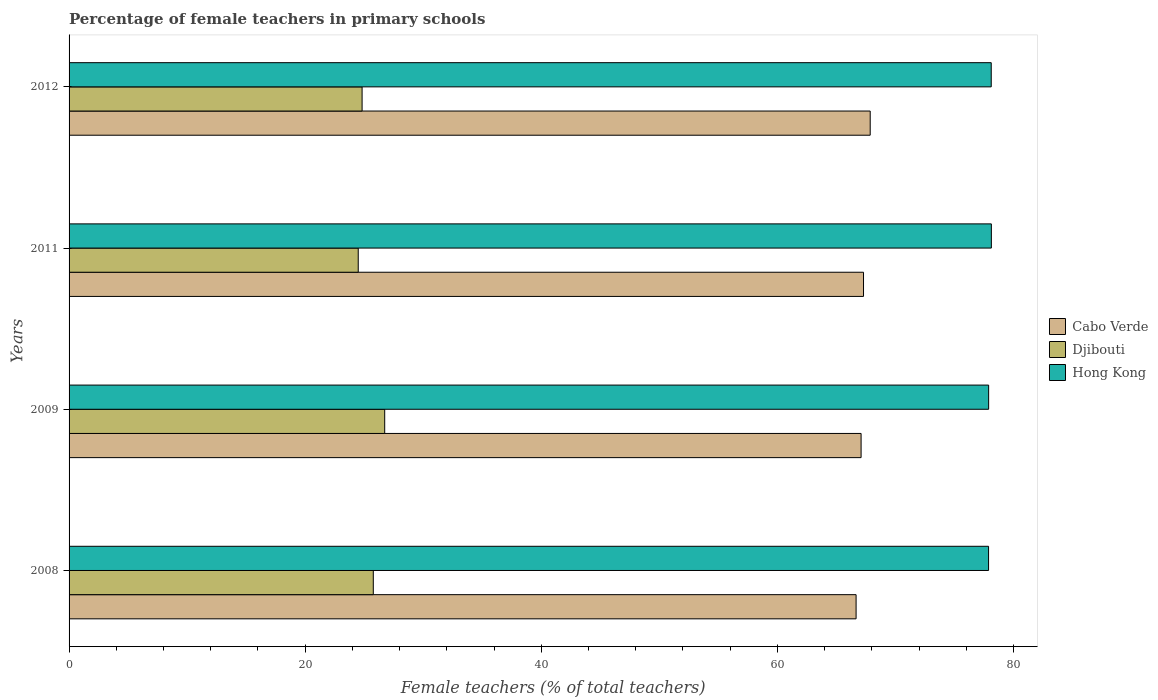Are the number of bars per tick equal to the number of legend labels?
Give a very brief answer. Yes. Are the number of bars on each tick of the Y-axis equal?
Give a very brief answer. Yes. How many bars are there on the 4th tick from the top?
Make the answer very short. 3. How many bars are there on the 1st tick from the bottom?
Offer a very short reply. 3. In how many cases, is the number of bars for a given year not equal to the number of legend labels?
Provide a succinct answer. 0. What is the percentage of female teachers in Cabo Verde in 2009?
Provide a short and direct response. 67.09. Across all years, what is the maximum percentage of female teachers in Hong Kong?
Your answer should be very brief. 78.12. Across all years, what is the minimum percentage of female teachers in Djibouti?
Offer a very short reply. 24.49. In which year was the percentage of female teachers in Hong Kong maximum?
Provide a short and direct response. 2011. What is the total percentage of female teachers in Cabo Verde in the graph?
Ensure brevity in your answer.  268.91. What is the difference between the percentage of female teachers in Hong Kong in 2009 and that in 2011?
Ensure brevity in your answer.  -0.23. What is the difference between the percentage of female teachers in Cabo Verde in 2009 and the percentage of female teachers in Djibouti in 2012?
Your response must be concise. 42.27. What is the average percentage of female teachers in Hong Kong per year?
Your answer should be compact. 78. In the year 2012, what is the difference between the percentage of female teachers in Djibouti and percentage of female teachers in Cabo Verde?
Your response must be concise. -43.04. In how many years, is the percentage of female teachers in Cabo Verde greater than 12 %?
Provide a succinct answer. 4. What is the ratio of the percentage of female teachers in Cabo Verde in 2008 to that in 2011?
Give a very brief answer. 0.99. Is the percentage of female teachers in Hong Kong in 2008 less than that in 2011?
Provide a short and direct response. Yes. Is the difference between the percentage of female teachers in Djibouti in 2008 and 2011 greater than the difference between the percentage of female teachers in Cabo Verde in 2008 and 2011?
Offer a terse response. Yes. What is the difference between the highest and the second highest percentage of female teachers in Hong Kong?
Provide a succinct answer. 0.01. What is the difference between the highest and the lowest percentage of female teachers in Djibouti?
Offer a very short reply. 2.24. Is the sum of the percentage of female teachers in Djibouti in 2008 and 2011 greater than the maximum percentage of female teachers in Hong Kong across all years?
Your answer should be compact. No. What does the 3rd bar from the top in 2009 represents?
Make the answer very short. Cabo Verde. What does the 3rd bar from the bottom in 2011 represents?
Offer a very short reply. Hong Kong. Is it the case that in every year, the sum of the percentage of female teachers in Cabo Verde and percentage of female teachers in Hong Kong is greater than the percentage of female teachers in Djibouti?
Your answer should be compact. Yes. How many bars are there?
Offer a terse response. 12. How many years are there in the graph?
Provide a succinct answer. 4. What is the difference between two consecutive major ticks on the X-axis?
Make the answer very short. 20. Does the graph contain any zero values?
Offer a very short reply. No. Does the graph contain grids?
Keep it short and to the point. No. How are the legend labels stacked?
Keep it short and to the point. Vertical. What is the title of the graph?
Ensure brevity in your answer.  Percentage of female teachers in primary schools. What is the label or title of the X-axis?
Your answer should be compact. Female teachers (% of total teachers). What is the Female teachers (% of total teachers) in Cabo Verde in 2008?
Give a very brief answer. 66.67. What is the Female teachers (% of total teachers) of Djibouti in 2008?
Your answer should be compact. 25.77. What is the Female teachers (% of total teachers) of Hong Kong in 2008?
Give a very brief answer. 77.89. What is the Female teachers (% of total teachers) in Cabo Verde in 2009?
Provide a short and direct response. 67.09. What is the Female teachers (% of total teachers) in Djibouti in 2009?
Keep it short and to the point. 26.74. What is the Female teachers (% of total teachers) in Hong Kong in 2009?
Offer a terse response. 77.89. What is the Female teachers (% of total teachers) in Cabo Verde in 2011?
Keep it short and to the point. 67.29. What is the Female teachers (% of total teachers) in Djibouti in 2011?
Make the answer very short. 24.49. What is the Female teachers (% of total teachers) in Hong Kong in 2011?
Your answer should be compact. 78.12. What is the Female teachers (% of total teachers) of Cabo Verde in 2012?
Offer a terse response. 67.86. What is the Female teachers (% of total teachers) of Djibouti in 2012?
Make the answer very short. 24.82. What is the Female teachers (% of total teachers) in Hong Kong in 2012?
Your response must be concise. 78.11. Across all years, what is the maximum Female teachers (% of total teachers) in Cabo Verde?
Offer a very short reply. 67.86. Across all years, what is the maximum Female teachers (% of total teachers) of Djibouti?
Make the answer very short. 26.74. Across all years, what is the maximum Female teachers (% of total teachers) in Hong Kong?
Provide a short and direct response. 78.12. Across all years, what is the minimum Female teachers (% of total teachers) of Cabo Verde?
Ensure brevity in your answer.  66.67. Across all years, what is the minimum Female teachers (% of total teachers) in Djibouti?
Your answer should be compact. 24.49. Across all years, what is the minimum Female teachers (% of total teachers) of Hong Kong?
Offer a very short reply. 77.89. What is the total Female teachers (% of total teachers) in Cabo Verde in the graph?
Keep it short and to the point. 268.91. What is the total Female teachers (% of total teachers) in Djibouti in the graph?
Ensure brevity in your answer.  101.82. What is the total Female teachers (% of total teachers) of Hong Kong in the graph?
Your answer should be very brief. 312.02. What is the difference between the Female teachers (% of total teachers) of Cabo Verde in 2008 and that in 2009?
Offer a very short reply. -0.42. What is the difference between the Female teachers (% of total teachers) of Djibouti in 2008 and that in 2009?
Your answer should be compact. -0.97. What is the difference between the Female teachers (% of total teachers) in Hong Kong in 2008 and that in 2009?
Provide a succinct answer. -0.01. What is the difference between the Female teachers (% of total teachers) of Cabo Verde in 2008 and that in 2011?
Provide a succinct answer. -0.63. What is the difference between the Female teachers (% of total teachers) of Djibouti in 2008 and that in 2011?
Provide a succinct answer. 1.27. What is the difference between the Female teachers (% of total teachers) of Hong Kong in 2008 and that in 2011?
Your answer should be compact. -0.24. What is the difference between the Female teachers (% of total teachers) in Cabo Verde in 2008 and that in 2012?
Offer a terse response. -1.2. What is the difference between the Female teachers (% of total teachers) of Djibouti in 2008 and that in 2012?
Provide a succinct answer. 0.95. What is the difference between the Female teachers (% of total teachers) in Hong Kong in 2008 and that in 2012?
Make the answer very short. -0.23. What is the difference between the Female teachers (% of total teachers) in Cabo Verde in 2009 and that in 2011?
Your answer should be compact. -0.2. What is the difference between the Female teachers (% of total teachers) of Djibouti in 2009 and that in 2011?
Provide a short and direct response. 2.24. What is the difference between the Female teachers (% of total teachers) of Hong Kong in 2009 and that in 2011?
Offer a very short reply. -0.23. What is the difference between the Female teachers (% of total teachers) in Cabo Verde in 2009 and that in 2012?
Give a very brief answer. -0.77. What is the difference between the Female teachers (% of total teachers) in Djibouti in 2009 and that in 2012?
Your answer should be compact. 1.91. What is the difference between the Female teachers (% of total teachers) of Hong Kong in 2009 and that in 2012?
Offer a terse response. -0.22. What is the difference between the Female teachers (% of total teachers) in Cabo Verde in 2011 and that in 2012?
Provide a short and direct response. -0.57. What is the difference between the Female teachers (% of total teachers) in Djibouti in 2011 and that in 2012?
Make the answer very short. -0.33. What is the difference between the Female teachers (% of total teachers) in Hong Kong in 2011 and that in 2012?
Make the answer very short. 0.01. What is the difference between the Female teachers (% of total teachers) of Cabo Verde in 2008 and the Female teachers (% of total teachers) of Djibouti in 2009?
Your answer should be compact. 39.93. What is the difference between the Female teachers (% of total teachers) in Cabo Verde in 2008 and the Female teachers (% of total teachers) in Hong Kong in 2009?
Ensure brevity in your answer.  -11.23. What is the difference between the Female teachers (% of total teachers) in Djibouti in 2008 and the Female teachers (% of total teachers) in Hong Kong in 2009?
Ensure brevity in your answer.  -52.12. What is the difference between the Female teachers (% of total teachers) in Cabo Verde in 2008 and the Female teachers (% of total teachers) in Djibouti in 2011?
Offer a terse response. 42.17. What is the difference between the Female teachers (% of total teachers) of Cabo Verde in 2008 and the Female teachers (% of total teachers) of Hong Kong in 2011?
Keep it short and to the point. -11.46. What is the difference between the Female teachers (% of total teachers) of Djibouti in 2008 and the Female teachers (% of total teachers) of Hong Kong in 2011?
Give a very brief answer. -52.35. What is the difference between the Female teachers (% of total teachers) of Cabo Verde in 2008 and the Female teachers (% of total teachers) of Djibouti in 2012?
Offer a terse response. 41.85. What is the difference between the Female teachers (% of total teachers) of Cabo Verde in 2008 and the Female teachers (% of total teachers) of Hong Kong in 2012?
Your response must be concise. -11.45. What is the difference between the Female teachers (% of total teachers) of Djibouti in 2008 and the Female teachers (% of total teachers) of Hong Kong in 2012?
Your answer should be compact. -52.34. What is the difference between the Female teachers (% of total teachers) of Cabo Verde in 2009 and the Female teachers (% of total teachers) of Djibouti in 2011?
Your answer should be very brief. 42.6. What is the difference between the Female teachers (% of total teachers) of Cabo Verde in 2009 and the Female teachers (% of total teachers) of Hong Kong in 2011?
Keep it short and to the point. -11.03. What is the difference between the Female teachers (% of total teachers) of Djibouti in 2009 and the Female teachers (% of total teachers) of Hong Kong in 2011?
Keep it short and to the point. -51.39. What is the difference between the Female teachers (% of total teachers) of Cabo Verde in 2009 and the Female teachers (% of total teachers) of Djibouti in 2012?
Your answer should be very brief. 42.27. What is the difference between the Female teachers (% of total teachers) of Cabo Verde in 2009 and the Female teachers (% of total teachers) of Hong Kong in 2012?
Keep it short and to the point. -11.02. What is the difference between the Female teachers (% of total teachers) in Djibouti in 2009 and the Female teachers (% of total teachers) in Hong Kong in 2012?
Provide a succinct answer. -51.38. What is the difference between the Female teachers (% of total teachers) of Cabo Verde in 2011 and the Female teachers (% of total teachers) of Djibouti in 2012?
Give a very brief answer. 42.47. What is the difference between the Female teachers (% of total teachers) in Cabo Verde in 2011 and the Female teachers (% of total teachers) in Hong Kong in 2012?
Make the answer very short. -10.82. What is the difference between the Female teachers (% of total teachers) of Djibouti in 2011 and the Female teachers (% of total teachers) of Hong Kong in 2012?
Your answer should be compact. -53.62. What is the average Female teachers (% of total teachers) of Cabo Verde per year?
Your answer should be compact. 67.23. What is the average Female teachers (% of total teachers) of Djibouti per year?
Offer a terse response. 25.46. What is the average Female teachers (% of total teachers) of Hong Kong per year?
Ensure brevity in your answer.  78. In the year 2008, what is the difference between the Female teachers (% of total teachers) in Cabo Verde and Female teachers (% of total teachers) in Djibouti?
Provide a short and direct response. 40.9. In the year 2008, what is the difference between the Female teachers (% of total teachers) in Cabo Verde and Female teachers (% of total teachers) in Hong Kong?
Your answer should be very brief. -11.22. In the year 2008, what is the difference between the Female teachers (% of total teachers) of Djibouti and Female teachers (% of total teachers) of Hong Kong?
Your answer should be very brief. -52.12. In the year 2009, what is the difference between the Female teachers (% of total teachers) of Cabo Verde and Female teachers (% of total teachers) of Djibouti?
Give a very brief answer. 40.35. In the year 2009, what is the difference between the Female teachers (% of total teachers) in Cabo Verde and Female teachers (% of total teachers) in Hong Kong?
Give a very brief answer. -10.8. In the year 2009, what is the difference between the Female teachers (% of total teachers) in Djibouti and Female teachers (% of total teachers) in Hong Kong?
Offer a very short reply. -51.16. In the year 2011, what is the difference between the Female teachers (% of total teachers) in Cabo Verde and Female teachers (% of total teachers) in Djibouti?
Offer a terse response. 42.8. In the year 2011, what is the difference between the Female teachers (% of total teachers) of Cabo Verde and Female teachers (% of total teachers) of Hong Kong?
Offer a terse response. -10.83. In the year 2011, what is the difference between the Female teachers (% of total teachers) in Djibouti and Female teachers (% of total teachers) in Hong Kong?
Offer a terse response. -53.63. In the year 2012, what is the difference between the Female teachers (% of total teachers) of Cabo Verde and Female teachers (% of total teachers) of Djibouti?
Offer a very short reply. 43.04. In the year 2012, what is the difference between the Female teachers (% of total teachers) of Cabo Verde and Female teachers (% of total teachers) of Hong Kong?
Provide a succinct answer. -10.25. In the year 2012, what is the difference between the Female teachers (% of total teachers) in Djibouti and Female teachers (% of total teachers) in Hong Kong?
Make the answer very short. -53.29. What is the ratio of the Female teachers (% of total teachers) in Djibouti in 2008 to that in 2009?
Provide a short and direct response. 0.96. What is the ratio of the Female teachers (% of total teachers) in Djibouti in 2008 to that in 2011?
Your response must be concise. 1.05. What is the ratio of the Female teachers (% of total teachers) in Cabo Verde in 2008 to that in 2012?
Give a very brief answer. 0.98. What is the ratio of the Female teachers (% of total teachers) of Djibouti in 2008 to that in 2012?
Your answer should be very brief. 1.04. What is the ratio of the Female teachers (% of total teachers) of Cabo Verde in 2009 to that in 2011?
Your response must be concise. 1. What is the ratio of the Female teachers (% of total teachers) of Djibouti in 2009 to that in 2011?
Provide a succinct answer. 1.09. What is the ratio of the Female teachers (% of total teachers) in Hong Kong in 2009 to that in 2011?
Give a very brief answer. 1. What is the ratio of the Female teachers (% of total teachers) of Cabo Verde in 2009 to that in 2012?
Provide a short and direct response. 0.99. What is the ratio of the Female teachers (% of total teachers) of Djibouti in 2009 to that in 2012?
Provide a short and direct response. 1.08. What is the ratio of the Female teachers (% of total teachers) in Hong Kong in 2009 to that in 2012?
Offer a very short reply. 1. What is the ratio of the Female teachers (% of total teachers) of Cabo Verde in 2011 to that in 2012?
Your answer should be very brief. 0.99. What is the ratio of the Female teachers (% of total teachers) of Hong Kong in 2011 to that in 2012?
Offer a terse response. 1. What is the difference between the highest and the second highest Female teachers (% of total teachers) of Cabo Verde?
Give a very brief answer. 0.57. What is the difference between the highest and the second highest Female teachers (% of total teachers) in Djibouti?
Your answer should be very brief. 0.97. What is the difference between the highest and the second highest Female teachers (% of total teachers) in Hong Kong?
Offer a terse response. 0.01. What is the difference between the highest and the lowest Female teachers (% of total teachers) in Cabo Verde?
Provide a short and direct response. 1.2. What is the difference between the highest and the lowest Female teachers (% of total teachers) in Djibouti?
Make the answer very short. 2.24. What is the difference between the highest and the lowest Female teachers (% of total teachers) in Hong Kong?
Your response must be concise. 0.24. 